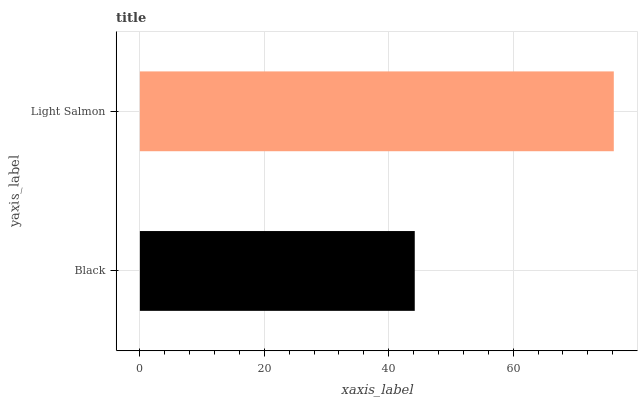Is Black the minimum?
Answer yes or no. Yes. Is Light Salmon the maximum?
Answer yes or no. Yes. Is Light Salmon the minimum?
Answer yes or no. No. Is Light Salmon greater than Black?
Answer yes or no. Yes. Is Black less than Light Salmon?
Answer yes or no. Yes. Is Black greater than Light Salmon?
Answer yes or no. No. Is Light Salmon less than Black?
Answer yes or no. No. Is Light Salmon the high median?
Answer yes or no. Yes. Is Black the low median?
Answer yes or no. Yes. Is Black the high median?
Answer yes or no. No. Is Light Salmon the low median?
Answer yes or no. No. 